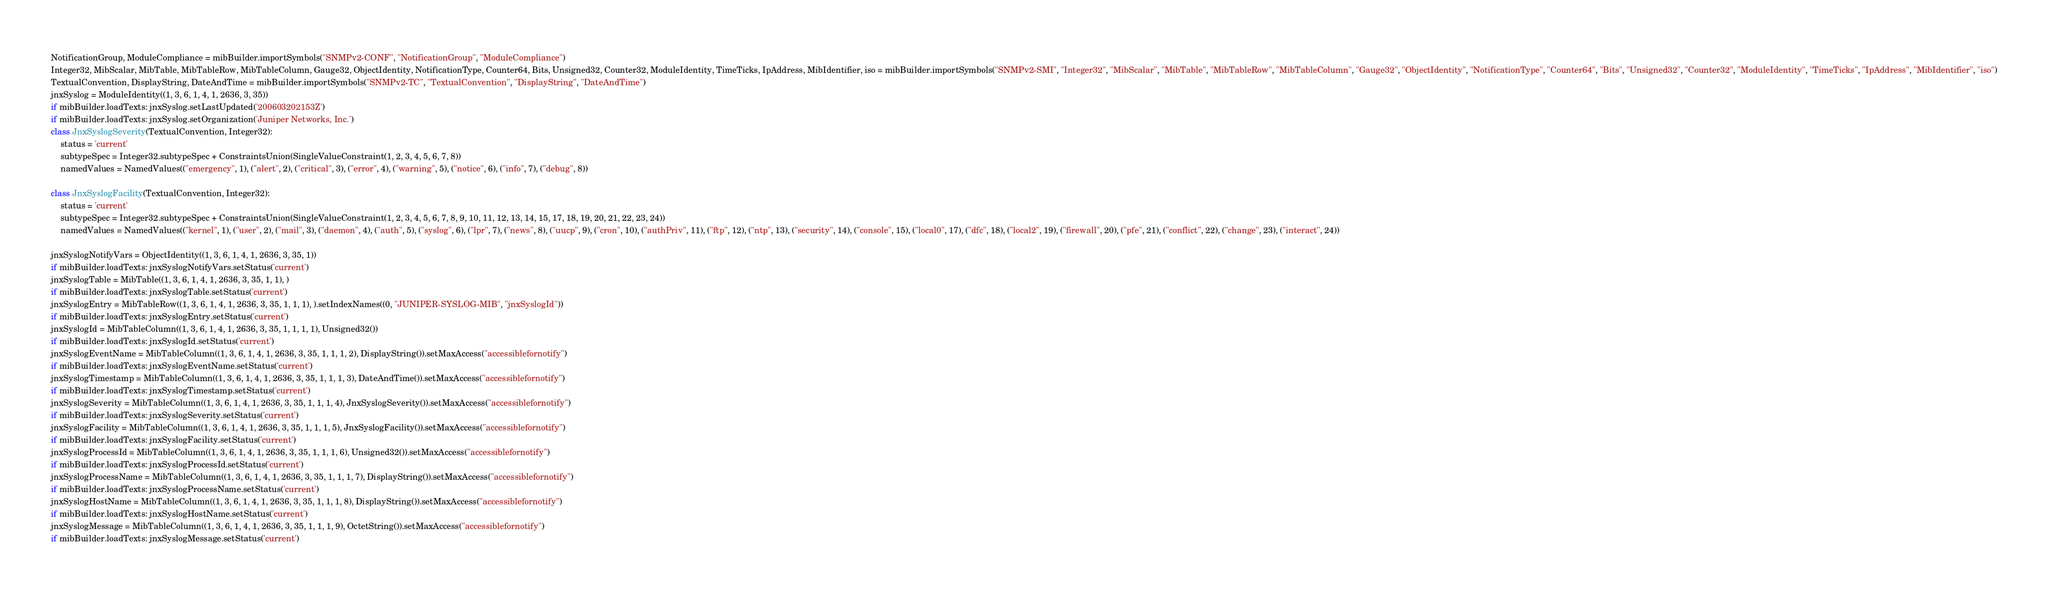Convert code to text. <code><loc_0><loc_0><loc_500><loc_500><_Python_>NotificationGroup, ModuleCompliance = mibBuilder.importSymbols("SNMPv2-CONF", "NotificationGroup", "ModuleCompliance")
Integer32, MibScalar, MibTable, MibTableRow, MibTableColumn, Gauge32, ObjectIdentity, NotificationType, Counter64, Bits, Unsigned32, Counter32, ModuleIdentity, TimeTicks, IpAddress, MibIdentifier, iso = mibBuilder.importSymbols("SNMPv2-SMI", "Integer32", "MibScalar", "MibTable", "MibTableRow", "MibTableColumn", "Gauge32", "ObjectIdentity", "NotificationType", "Counter64", "Bits", "Unsigned32", "Counter32", "ModuleIdentity", "TimeTicks", "IpAddress", "MibIdentifier", "iso")
TextualConvention, DisplayString, DateAndTime = mibBuilder.importSymbols("SNMPv2-TC", "TextualConvention", "DisplayString", "DateAndTime")
jnxSyslog = ModuleIdentity((1, 3, 6, 1, 4, 1, 2636, 3, 35))
if mibBuilder.loadTexts: jnxSyslog.setLastUpdated('200603202153Z')
if mibBuilder.loadTexts: jnxSyslog.setOrganization('Juniper Networks, Inc.')
class JnxSyslogSeverity(TextualConvention, Integer32):
    status = 'current'
    subtypeSpec = Integer32.subtypeSpec + ConstraintsUnion(SingleValueConstraint(1, 2, 3, 4, 5, 6, 7, 8))
    namedValues = NamedValues(("emergency", 1), ("alert", 2), ("critical", 3), ("error", 4), ("warning", 5), ("notice", 6), ("info", 7), ("debug", 8))

class JnxSyslogFacility(TextualConvention, Integer32):
    status = 'current'
    subtypeSpec = Integer32.subtypeSpec + ConstraintsUnion(SingleValueConstraint(1, 2, 3, 4, 5, 6, 7, 8, 9, 10, 11, 12, 13, 14, 15, 17, 18, 19, 20, 21, 22, 23, 24))
    namedValues = NamedValues(("kernel", 1), ("user", 2), ("mail", 3), ("daemon", 4), ("auth", 5), ("syslog", 6), ("lpr", 7), ("news", 8), ("uucp", 9), ("cron", 10), ("authPriv", 11), ("ftp", 12), ("ntp", 13), ("security", 14), ("console", 15), ("local0", 17), ("dfc", 18), ("local2", 19), ("firewall", 20), ("pfe", 21), ("conflict", 22), ("change", 23), ("interact", 24))

jnxSyslogNotifyVars = ObjectIdentity((1, 3, 6, 1, 4, 1, 2636, 3, 35, 1))
if mibBuilder.loadTexts: jnxSyslogNotifyVars.setStatus('current')
jnxSyslogTable = MibTable((1, 3, 6, 1, 4, 1, 2636, 3, 35, 1, 1), )
if mibBuilder.loadTexts: jnxSyslogTable.setStatus('current')
jnxSyslogEntry = MibTableRow((1, 3, 6, 1, 4, 1, 2636, 3, 35, 1, 1, 1), ).setIndexNames((0, "JUNIPER-SYSLOG-MIB", "jnxSyslogId"))
if mibBuilder.loadTexts: jnxSyslogEntry.setStatus('current')
jnxSyslogId = MibTableColumn((1, 3, 6, 1, 4, 1, 2636, 3, 35, 1, 1, 1, 1), Unsigned32())
if mibBuilder.loadTexts: jnxSyslogId.setStatus('current')
jnxSyslogEventName = MibTableColumn((1, 3, 6, 1, 4, 1, 2636, 3, 35, 1, 1, 1, 2), DisplayString()).setMaxAccess("accessiblefornotify")
if mibBuilder.loadTexts: jnxSyslogEventName.setStatus('current')
jnxSyslogTimestamp = MibTableColumn((1, 3, 6, 1, 4, 1, 2636, 3, 35, 1, 1, 1, 3), DateAndTime()).setMaxAccess("accessiblefornotify")
if mibBuilder.loadTexts: jnxSyslogTimestamp.setStatus('current')
jnxSyslogSeverity = MibTableColumn((1, 3, 6, 1, 4, 1, 2636, 3, 35, 1, 1, 1, 4), JnxSyslogSeverity()).setMaxAccess("accessiblefornotify")
if mibBuilder.loadTexts: jnxSyslogSeverity.setStatus('current')
jnxSyslogFacility = MibTableColumn((1, 3, 6, 1, 4, 1, 2636, 3, 35, 1, 1, 1, 5), JnxSyslogFacility()).setMaxAccess("accessiblefornotify")
if mibBuilder.loadTexts: jnxSyslogFacility.setStatus('current')
jnxSyslogProcessId = MibTableColumn((1, 3, 6, 1, 4, 1, 2636, 3, 35, 1, 1, 1, 6), Unsigned32()).setMaxAccess("accessiblefornotify")
if mibBuilder.loadTexts: jnxSyslogProcessId.setStatus('current')
jnxSyslogProcessName = MibTableColumn((1, 3, 6, 1, 4, 1, 2636, 3, 35, 1, 1, 1, 7), DisplayString()).setMaxAccess("accessiblefornotify")
if mibBuilder.loadTexts: jnxSyslogProcessName.setStatus('current')
jnxSyslogHostName = MibTableColumn((1, 3, 6, 1, 4, 1, 2636, 3, 35, 1, 1, 1, 8), DisplayString()).setMaxAccess("accessiblefornotify")
if mibBuilder.loadTexts: jnxSyslogHostName.setStatus('current')
jnxSyslogMessage = MibTableColumn((1, 3, 6, 1, 4, 1, 2636, 3, 35, 1, 1, 1, 9), OctetString()).setMaxAccess("accessiblefornotify")
if mibBuilder.loadTexts: jnxSyslogMessage.setStatus('current')</code> 